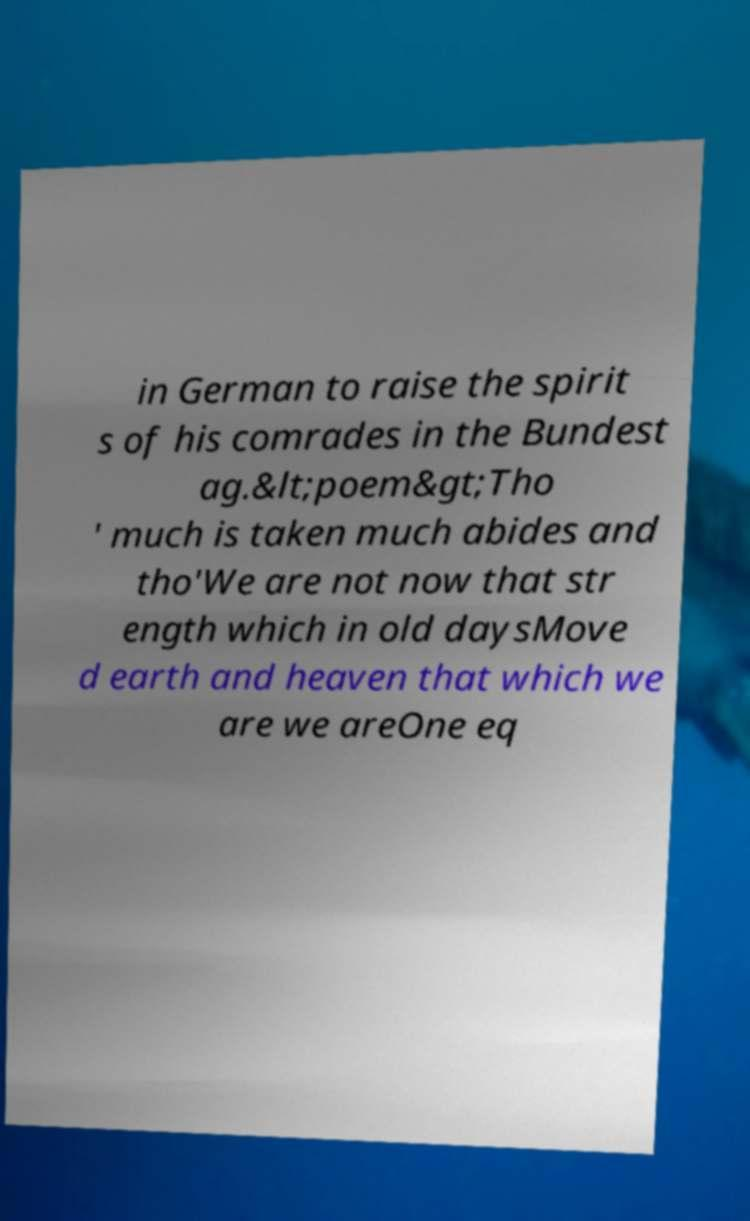I need the written content from this picture converted into text. Can you do that? in German to raise the spirit s of his comrades in the Bundest ag.&lt;poem&gt;Tho ' much is taken much abides and tho'We are not now that str ength which in old daysMove d earth and heaven that which we are we areOne eq 